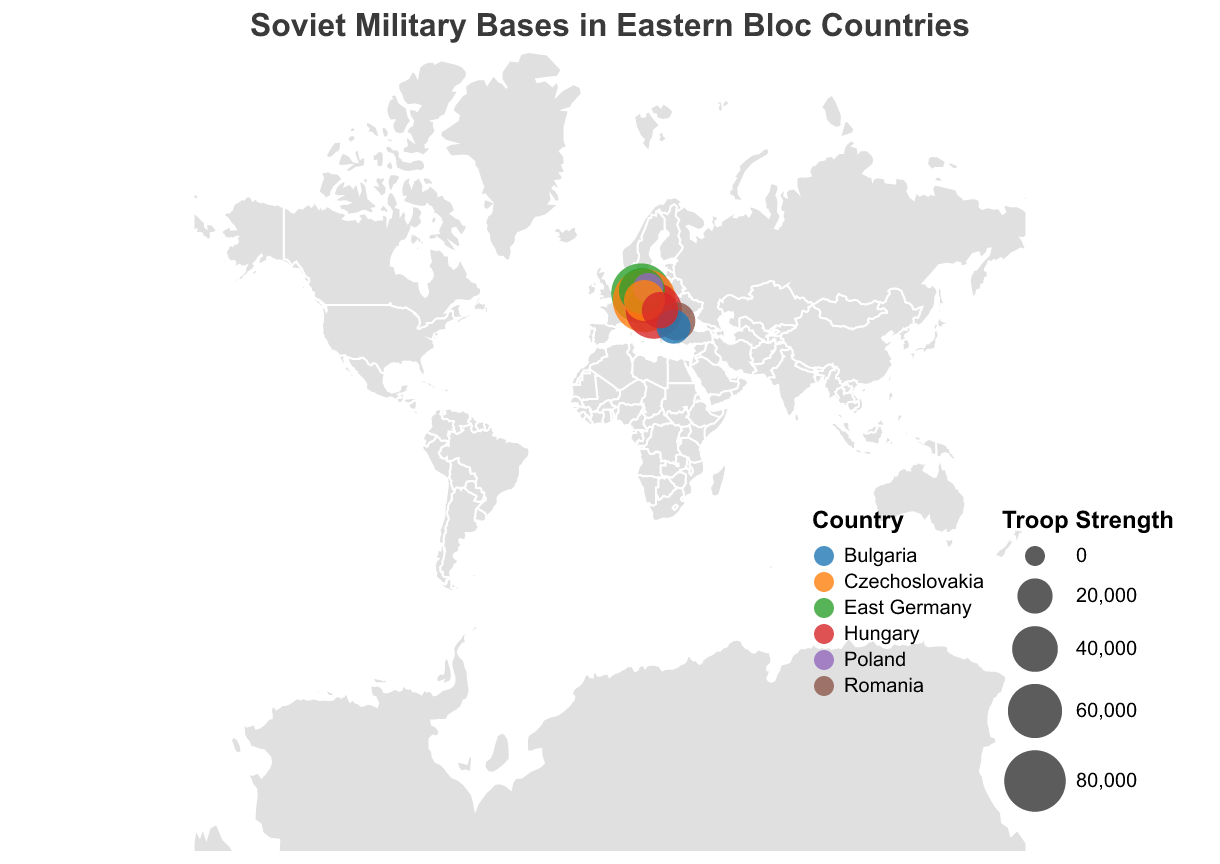How many Soviet military bases are indicated in the figure? By counting the number of circle markers on the map, we can determine the number of Soviet military bases.
Answer: 10 Which country has the base with the highest troop strength? By observing the size of the circle markers and checking the tooltip details for troop strength, we can identify the base with the largest circle. The base with 85,000 troops in Czechoslovakia is the largest.
Answer: Czechoslovakia Which base in Hungary has the higher troop strength, and by how much? There are two bases in Hungary: Tököl and Debrecen. The troop strength for Tököl is 65,000 and for Debrecen is 22,000. To find the difference, subtract 22,000 from 65,000.
Answer: Tököl, by 43,000 Which country has the most Soviet military bases based on the figure? By looking at the colors representing different countries and counting the number of bases represented for each country, we can determine which country has the most bases. East Germany has two bases, while others have one each.
Answer: East Germany What is the average troop strength of the Soviet military bases in Poland? There are two bases in Poland: Legnica with 58,000 troops and Borne Sulinowo with 12,000 troops. Sum these to get 70,000 and then divide by 2 (the number of bases) to find the average.
Answer: 35,000 Compare the troop strength of the bases in Czechoslovakia to those in East Germany. Which country has the larger total troop strength? In Czechoslovakia, there are two bases: Milovice (85,000) and Mladá (30,000), summing to 115,000. In East Germany, there are also two bases: Wünsdorf (75,000) and Eberswalde (40,000), summing to 115,000. Comparing these sums, both countries have equal total troop strength.
Answer: Equal What is the smallest troop strength indicated in the figure and which base does it belong to? By examining the circle sizes and their tooltip data, the smallest troop strength is 12,000 at the Borne Sulinowo base in Poland.
Answer: 12,000, Borne Sulinowo Identify the geographical distribution of troop strength. Which region appears to have the highest concentration of troops? By observing the cluster of large circle markers and their tooltip data, the central region involving Poland, East Germany, and Czechoslovakia shows the highest concentration of troop strength.
Answer: Central region (East Germany, Poland, Czechoslovakia) How many bases in the figure are located in coastal cities? By observing the map and the circle markers near coastlines, and using the tooltip to confirm city names, we find that Constanta in Romania and Burgas in Bulgaria are coastal cities with bases.
Answer: 2 Which country's base is located furthest south? By looking at the geographic plot, the base in Burgas, Bulgaria, appears furthest south.
Answer: Bulgaria 